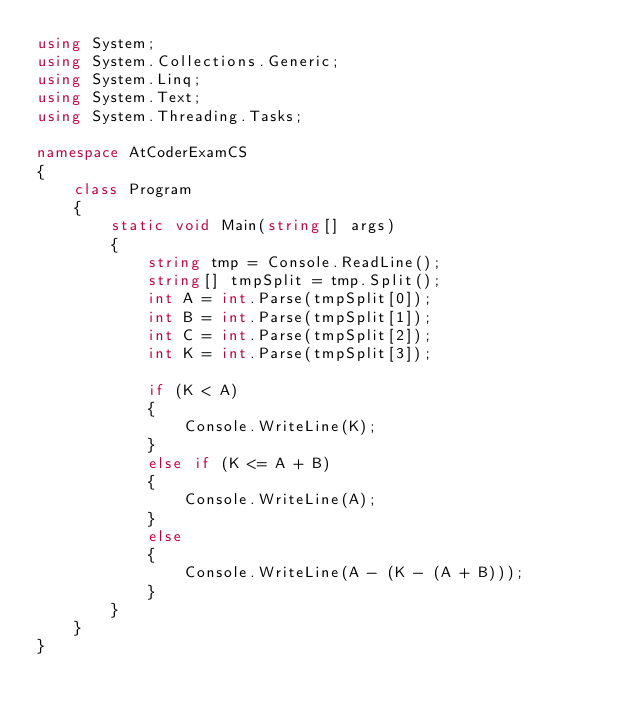<code> <loc_0><loc_0><loc_500><loc_500><_C#_>using System;
using System.Collections.Generic;
using System.Linq;
using System.Text;
using System.Threading.Tasks;

namespace AtCoderExamCS
{
    class Program
    {
        static void Main(string[] args)
        {
            string tmp = Console.ReadLine();
            string[] tmpSplit = tmp.Split();
            int A = int.Parse(tmpSplit[0]);
            int B = int.Parse(tmpSplit[1]);
            int C = int.Parse(tmpSplit[2]);
            int K = int.Parse(tmpSplit[3]);

            if (K < A)
            {
                Console.WriteLine(K);
            }
            else if (K <= A + B)
            {
                Console.WriteLine(A);
            }
            else
            {
                Console.WriteLine(A - (K - (A + B)));
            }
        }
    }
}
</code> 